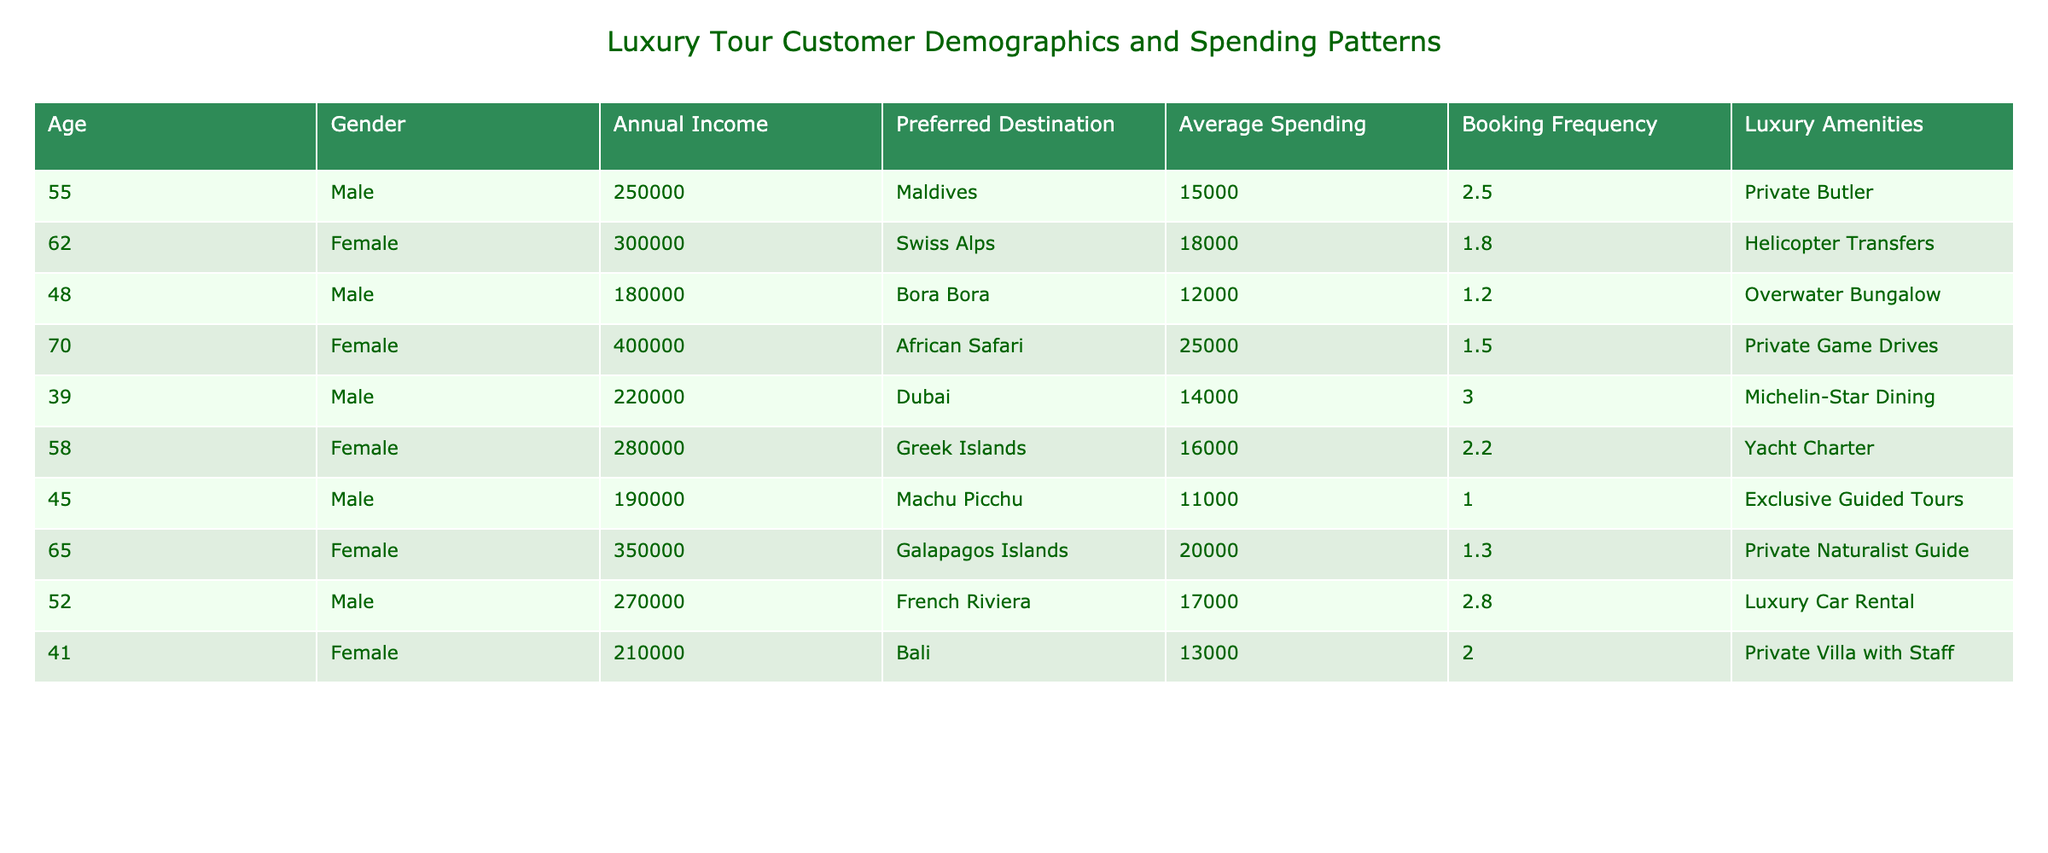What is the average annual income of all customers? To find the average annual income, we sum the annual incomes: (250000 + 300000 + 180000 + 400000 + 220000 + 280000 + 190000 + 350000 + 270000 + 210000) = 2350000. There are 10 customers, so the average annual income is 2350000/10 = 235000.
Answer: 235000 Which customer has the highest average spending? By examining the Average Spending column, the highest value is 25000, associated with the customer who prefers African Safari.
Answer: 25000 How many customers prefer destinations in Europe? The preferred destinations in Europe are Swiss Alps, Greek Islands, and French Riviera. This counts to 3 customers.
Answer: 3 Is there any customer that books luxury tours more than three times a year? None of the customers have a booking frequency greater than 3, as the highest is 3.0.
Answer: No What is the total average spending of male customers? Summing the average spending of male customers: (15000 + 12000 + 14000 + 17000 + 13000) = 71000. There are 5 male customers, so the average is 71000/5 = 14200.
Answer: 14200 Which gender has a higher average annual income? The average annual income for females is (300000 + 400000 + 280000 + 350000 + 210000) = 1540000, giving an average of 1540000/5 = 308000. For males: (250000 + 180000 + 220000 + 270000 + 190000) = 1110000, with an average of 1110000/5 = 222000. Since 308000 > 222000, females have a higher average.
Answer: Female What is the total average spending difference between the two genders? The average spending for females is (18000 + 25000 + 16000 + 20000 + 13000) = 114000, with an average of 114000/5 = 22800. For males: (15000 + 12000 + 14000 + 17000 + 11000) = 71000, giving an average of 71000/5 = 14200. The difference is 22800 - 14200 = 8600.
Answer: 8600 Which preferred destination corresponds with the highest booking frequency? The highest booking frequency is 3.0 corresponding to the customer who prefers Dubai.
Answer: Dubai How does the average spending of customers aged above 50 compare to those below 50? For customers aged above 50: (15000 + 18000 + 25000 + 16000 + 17000) = 111000 with 5 customers, average is 111000/5 = 22200. For those below 50: (12000 + 14000 + 13000) = 39000 with 3 customers, average is 39000/3 = 13000. The difference is 22200 - 13000 = 9200.
Answer: 9200 Are there any customers who prefer both luxury amenities and have an average spending of more than 15000? Yes, customers who prefer Helicopter Transfers, Private Game Drives, and Private Naturalist Guide meet this criterion, as their average spending is above 15000.
Answer: Yes 